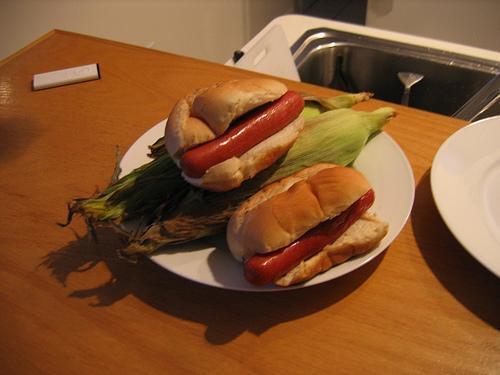Does the caption "The hot dog is at the edge of the dining table." correctly depict the image?
Answer yes or no. Yes. 